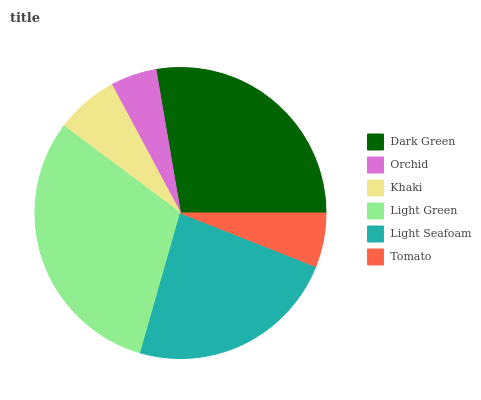Is Orchid the minimum?
Answer yes or no. Yes. Is Light Green the maximum?
Answer yes or no. Yes. Is Khaki the minimum?
Answer yes or no. No. Is Khaki the maximum?
Answer yes or no. No. Is Khaki greater than Orchid?
Answer yes or no. Yes. Is Orchid less than Khaki?
Answer yes or no. Yes. Is Orchid greater than Khaki?
Answer yes or no. No. Is Khaki less than Orchid?
Answer yes or no. No. Is Light Seafoam the high median?
Answer yes or no. Yes. Is Khaki the low median?
Answer yes or no. Yes. Is Dark Green the high median?
Answer yes or no. No. Is Light Green the low median?
Answer yes or no. No. 